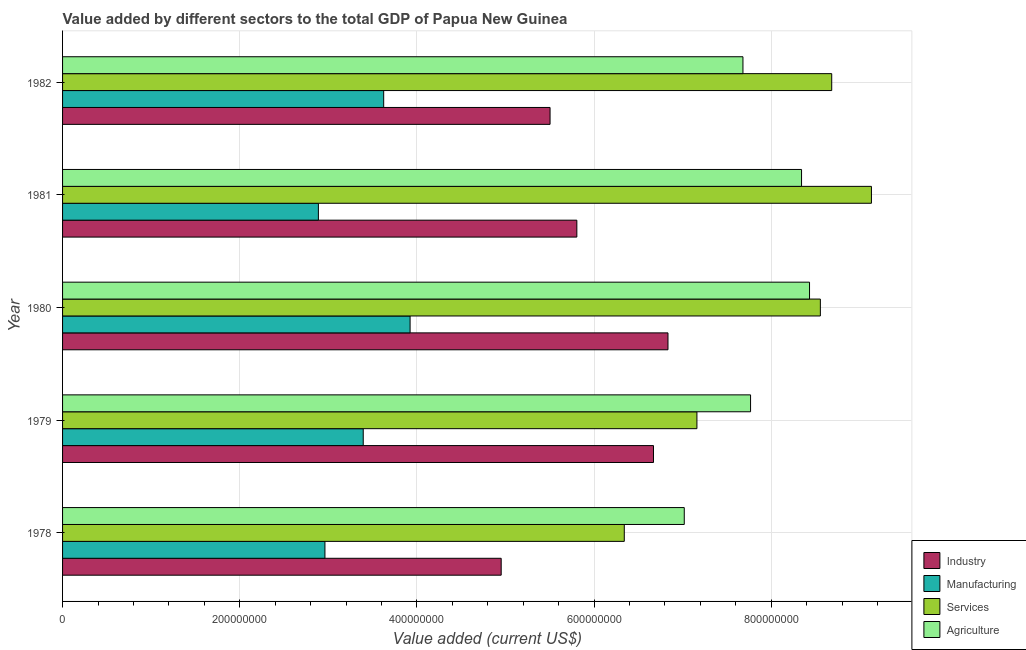How many groups of bars are there?
Provide a succinct answer. 5. Are the number of bars per tick equal to the number of legend labels?
Give a very brief answer. Yes. How many bars are there on the 1st tick from the top?
Offer a terse response. 4. How many bars are there on the 3rd tick from the bottom?
Make the answer very short. 4. What is the label of the 1st group of bars from the top?
Keep it short and to the point. 1982. In how many cases, is the number of bars for a given year not equal to the number of legend labels?
Offer a very short reply. 0. What is the value added by industrial sector in 1979?
Give a very brief answer. 6.67e+08. Across all years, what is the maximum value added by manufacturing sector?
Keep it short and to the point. 3.92e+08. Across all years, what is the minimum value added by services sector?
Make the answer very short. 6.34e+08. In which year was the value added by services sector minimum?
Ensure brevity in your answer.  1978. What is the total value added by services sector in the graph?
Your response must be concise. 3.99e+09. What is the difference between the value added by services sector in 1979 and that in 1980?
Offer a very short reply. -1.39e+08. What is the difference between the value added by services sector in 1982 and the value added by agricultural sector in 1978?
Give a very brief answer. 1.66e+08. What is the average value added by agricultural sector per year?
Your answer should be compact. 7.85e+08. In the year 1982, what is the difference between the value added by agricultural sector and value added by industrial sector?
Offer a very short reply. 2.18e+08. In how many years, is the value added by services sector greater than 160000000 US$?
Keep it short and to the point. 5. What is the ratio of the value added by industrial sector in 1978 to that in 1981?
Offer a terse response. 0.85. Is the value added by agricultural sector in 1978 less than that in 1979?
Your response must be concise. Yes. What is the difference between the highest and the second highest value added by industrial sector?
Give a very brief answer. 1.64e+07. What is the difference between the highest and the lowest value added by services sector?
Provide a short and direct response. 2.79e+08. In how many years, is the value added by agricultural sector greater than the average value added by agricultural sector taken over all years?
Make the answer very short. 2. What does the 3rd bar from the top in 1982 represents?
Provide a succinct answer. Manufacturing. What does the 1st bar from the bottom in 1978 represents?
Ensure brevity in your answer.  Industry. Is it the case that in every year, the sum of the value added by industrial sector and value added by manufacturing sector is greater than the value added by services sector?
Provide a short and direct response. No. How many years are there in the graph?
Keep it short and to the point. 5. What is the difference between two consecutive major ticks on the X-axis?
Your answer should be compact. 2.00e+08. Does the graph contain any zero values?
Make the answer very short. No. How many legend labels are there?
Give a very brief answer. 4. How are the legend labels stacked?
Make the answer very short. Vertical. What is the title of the graph?
Give a very brief answer. Value added by different sectors to the total GDP of Papua New Guinea. What is the label or title of the X-axis?
Keep it short and to the point. Value added (current US$). What is the Value added (current US$) in Industry in 1978?
Make the answer very short. 4.95e+08. What is the Value added (current US$) of Manufacturing in 1978?
Ensure brevity in your answer.  2.96e+08. What is the Value added (current US$) in Services in 1978?
Make the answer very short. 6.34e+08. What is the Value added (current US$) in Agriculture in 1978?
Your answer should be compact. 7.02e+08. What is the Value added (current US$) in Industry in 1979?
Your answer should be compact. 6.67e+08. What is the Value added (current US$) of Manufacturing in 1979?
Keep it short and to the point. 3.39e+08. What is the Value added (current US$) in Services in 1979?
Offer a terse response. 7.16e+08. What is the Value added (current US$) in Agriculture in 1979?
Provide a succinct answer. 7.77e+08. What is the Value added (current US$) of Industry in 1980?
Offer a terse response. 6.83e+08. What is the Value added (current US$) in Manufacturing in 1980?
Provide a succinct answer. 3.92e+08. What is the Value added (current US$) of Services in 1980?
Offer a very short reply. 8.55e+08. What is the Value added (current US$) in Agriculture in 1980?
Offer a terse response. 8.43e+08. What is the Value added (current US$) of Industry in 1981?
Make the answer very short. 5.81e+08. What is the Value added (current US$) in Manufacturing in 1981?
Provide a short and direct response. 2.89e+08. What is the Value added (current US$) in Services in 1981?
Offer a very short reply. 9.13e+08. What is the Value added (current US$) in Agriculture in 1981?
Your answer should be very brief. 8.34e+08. What is the Value added (current US$) of Industry in 1982?
Ensure brevity in your answer.  5.50e+08. What is the Value added (current US$) in Manufacturing in 1982?
Make the answer very short. 3.62e+08. What is the Value added (current US$) in Services in 1982?
Make the answer very short. 8.68e+08. What is the Value added (current US$) of Agriculture in 1982?
Your answer should be very brief. 7.68e+08. Across all years, what is the maximum Value added (current US$) in Industry?
Provide a succinct answer. 6.83e+08. Across all years, what is the maximum Value added (current US$) of Manufacturing?
Your answer should be compact. 3.92e+08. Across all years, what is the maximum Value added (current US$) of Services?
Provide a short and direct response. 9.13e+08. Across all years, what is the maximum Value added (current US$) in Agriculture?
Your response must be concise. 8.43e+08. Across all years, what is the minimum Value added (current US$) in Industry?
Your answer should be very brief. 4.95e+08. Across all years, what is the minimum Value added (current US$) in Manufacturing?
Your answer should be very brief. 2.89e+08. Across all years, what is the minimum Value added (current US$) in Services?
Offer a terse response. 6.34e+08. Across all years, what is the minimum Value added (current US$) in Agriculture?
Offer a terse response. 7.02e+08. What is the total Value added (current US$) of Industry in the graph?
Your answer should be very brief. 2.98e+09. What is the total Value added (current US$) in Manufacturing in the graph?
Give a very brief answer. 1.68e+09. What is the total Value added (current US$) of Services in the graph?
Provide a succinct answer. 3.99e+09. What is the total Value added (current US$) in Agriculture in the graph?
Your response must be concise. 3.92e+09. What is the difference between the Value added (current US$) of Industry in 1978 and that in 1979?
Ensure brevity in your answer.  -1.72e+08. What is the difference between the Value added (current US$) of Manufacturing in 1978 and that in 1979?
Your answer should be very brief. -4.32e+07. What is the difference between the Value added (current US$) of Services in 1978 and that in 1979?
Make the answer very short. -8.20e+07. What is the difference between the Value added (current US$) in Agriculture in 1978 and that in 1979?
Provide a succinct answer. -7.48e+07. What is the difference between the Value added (current US$) in Industry in 1978 and that in 1980?
Offer a very short reply. -1.88e+08. What is the difference between the Value added (current US$) in Manufacturing in 1978 and that in 1980?
Keep it short and to the point. -9.61e+07. What is the difference between the Value added (current US$) in Services in 1978 and that in 1980?
Your response must be concise. -2.21e+08. What is the difference between the Value added (current US$) in Agriculture in 1978 and that in 1980?
Your response must be concise. -1.41e+08. What is the difference between the Value added (current US$) of Industry in 1978 and that in 1981?
Provide a short and direct response. -8.54e+07. What is the difference between the Value added (current US$) in Manufacturing in 1978 and that in 1981?
Your answer should be compact. 7.40e+06. What is the difference between the Value added (current US$) in Services in 1978 and that in 1981?
Ensure brevity in your answer.  -2.79e+08. What is the difference between the Value added (current US$) in Agriculture in 1978 and that in 1981?
Your response must be concise. -1.32e+08. What is the difference between the Value added (current US$) of Industry in 1978 and that in 1982?
Provide a succinct answer. -5.52e+07. What is the difference between the Value added (current US$) of Manufacturing in 1978 and that in 1982?
Your answer should be compact. -6.63e+07. What is the difference between the Value added (current US$) in Services in 1978 and that in 1982?
Your response must be concise. -2.34e+08. What is the difference between the Value added (current US$) in Agriculture in 1978 and that in 1982?
Your answer should be compact. -6.63e+07. What is the difference between the Value added (current US$) of Industry in 1979 and that in 1980?
Your answer should be compact. -1.64e+07. What is the difference between the Value added (current US$) of Manufacturing in 1979 and that in 1980?
Offer a terse response. -5.29e+07. What is the difference between the Value added (current US$) of Services in 1979 and that in 1980?
Make the answer very short. -1.39e+08. What is the difference between the Value added (current US$) of Agriculture in 1979 and that in 1980?
Provide a short and direct response. -6.66e+07. What is the difference between the Value added (current US$) of Industry in 1979 and that in 1981?
Keep it short and to the point. 8.65e+07. What is the difference between the Value added (current US$) in Manufacturing in 1979 and that in 1981?
Make the answer very short. 5.06e+07. What is the difference between the Value added (current US$) in Services in 1979 and that in 1981?
Provide a succinct answer. -1.97e+08. What is the difference between the Value added (current US$) in Agriculture in 1979 and that in 1981?
Your answer should be very brief. -5.76e+07. What is the difference between the Value added (current US$) in Industry in 1979 and that in 1982?
Provide a succinct answer. 1.17e+08. What is the difference between the Value added (current US$) in Manufacturing in 1979 and that in 1982?
Provide a succinct answer. -2.31e+07. What is the difference between the Value added (current US$) in Services in 1979 and that in 1982?
Your answer should be very brief. -1.52e+08. What is the difference between the Value added (current US$) in Agriculture in 1979 and that in 1982?
Offer a terse response. 8.58e+06. What is the difference between the Value added (current US$) in Industry in 1980 and that in 1981?
Offer a terse response. 1.03e+08. What is the difference between the Value added (current US$) of Manufacturing in 1980 and that in 1981?
Your response must be concise. 1.04e+08. What is the difference between the Value added (current US$) of Services in 1980 and that in 1981?
Provide a succinct answer. -5.77e+07. What is the difference between the Value added (current US$) in Agriculture in 1980 and that in 1981?
Ensure brevity in your answer.  9.02e+06. What is the difference between the Value added (current US$) in Industry in 1980 and that in 1982?
Your response must be concise. 1.33e+08. What is the difference between the Value added (current US$) in Manufacturing in 1980 and that in 1982?
Your response must be concise. 2.98e+07. What is the difference between the Value added (current US$) of Services in 1980 and that in 1982?
Your answer should be very brief. -1.28e+07. What is the difference between the Value added (current US$) of Agriculture in 1980 and that in 1982?
Keep it short and to the point. 7.52e+07. What is the difference between the Value added (current US$) in Industry in 1981 and that in 1982?
Make the answer very short. 3.02e+07. What is the difference between the Value added (current US$) of Manufacturing in 1981 and that in 1982?
Make the answer very short. -7.37e+07. What is the difference between the Value added (current US$) in Services in 1981 and that in 1982?
Offer a terse response. 4.48e+07. What is the difference between the Value added (current US$) in Agriculture in 1981 and that in 1982?
Make the answer very short. 6.61e+07. What is the difference between the Value added (current US$) of Industry in 1978 and the Value added (current US$) of Manufacturing in 1979?
Keep it short and to the point. 1.56e+08. What is the difference between the Value added (current US$) of Industry in 1978 and the Value added (current US$) of Services in 1979?
Provide a short and direct response. -2.21e+08. What is the difference between the Value added (current US$) of Industry in 1978 and the Value added (current US$) of Agriculture in 1979?
Make the answer very short. -2.81e+08. What is the difference between the Value added (current US$) in Manufacturing in 1978 and the Value added (current US$) in Services in 1979?
Your answer should be very brief. -4.20e+08. What is the difference between the Value added (current US$) in Manufacturing in 1978 and the Value added (current US$) in Agriculture in 1979?
Your response must be concise. -4.80e+08. What is the difference between the Value added (current US$) in Services in 1978 and the Value added (current US$) in Agriculture in 1979?
Provide a short and direct response. -1.43e+08. What is the difference between the Value added (current US$) of Industry in 1978 and the Value added (current US$) of Manufacturing in 1980?
Give a very brief answer. 1.03e+08. What is the difference between the Value added (current US$) in Industry in 1978 and the Value added (current US$) in Services in 1980?
Your answer should be very brief. -3.60e+08. What is the difference between the Value added (current US$) of Industry in 1978 and the Value added (current US$) of Agriculture in 1980?
Offer a terse response. -3.48e+08. What is the difference between the Value added (current US$) of Manufacturing in 1978 and the Value added (current US$) of Services in 1980?
Your answer should be compact. -5.59e+08. What is the difference between the Value added (current US$) in Manufacturing in 1978 and the Value added (current US$) in Agriculture in 1980?
Provide a succinct answer. -5.47e+08. What is the difference between the Value added (current US$) of Services in 1978 and the Value added (current US$) of Agriculture in 1980?
Your answer should be compact. -2.09e+08. What is the difference between the Value added (current US$) in Industry in 1978 and the Value added (current US$) in Manufacturing in 1981?
Offer a terse response. 2.06e+08. What is the difference between the Value added (current US$) in Industry in 1978 and the Value added (current US$) in Services in 1981?
Ensure brevity in your answer.  -4.18e+08. What is the difference between the Value added (current US$) in Industry in 1978 and the Value added (current US$) in Agriculture in 1981?
Provide a short and direct response. -3.39e+08. What is the difference between the Value added (current US$) in Manufacturing in 1978 and the Value added (current US$) in Services in 1981?
Give a very brief answer. -6.17e+08. What is the difference between the Value added (current US$) of Manufacturing in 1978 and the Value added (current US$) of Agriculture in 1981?
Ensure brevity in your answer.  -5.38e+08. What is the difference between the Value added (current US$) in Services in 1978 and the Value added (current US$) in Agriculture in 1981?
Ensure brevity in your answer.  -2.00e+08. What is the difference between the Value added (current US$) of Industry in 1978 and the Value added (current US$) of Manufacturing in 1982?
Offer a very short reply. 1.33e+08. What is the difference between the Value added (current US$) in Industry in 1978 and the Value added (current US$) in Services in 1982?
Make the answer very short. -3.73e+08. What is the difference between the Value added (current US$) in Industry in 1978 and the Value added (current US$) in Agriculture in 1982?
Give a very brief answer. -2.73e+08. What is the difference between the Value added (current US$) in Manufacturing in 1978 and the Value added (current US$) in Services in 1982?
Offer a terse response. -5.72e+08. What is the difference between the Value added (current US$) of Manufacturing in 1978 and the Value added (current US$) of Agriculture in 1982?
Your answer should be compact. -4.72e+08. What is the difference between the Value added (current US$) of Services in 1978 and the Value added (current US$) of Agriculture in 1982?
Give a very brief answer. -1.34e+08. What is the difference between the Value added (current US$) of Industry in 1979 and the Value added (current US$) of Manufacturing in 1980?
Ensure brevity in your answer.  2.75e+08. What is the difference between the Value added (current US$) in Industry in 1979 and the Value added (current US$) in Services in 1980?
Your answer should be compact. -1.88e+08. What is the difference between the Value added (current US$) of Industry in 1979 and the Value added (current US$) of Agriculture in 1980?
Make the answer very short. -1.76e+08. What is the difference between the Value added (current US$) of Manufacturing in 1979 and the Value added (current US$) of Services in 1980?
Offer a terse response. -5.16e+08. What is the difference between the Value added (current US$) in Manufacturing in 1979 and the Value added (current US$) in Agriculture in 1980?
Your answer should be very brief. -5.04e+08. What is the difference between the Value added (current US$) in Services in 1979 and the Value added (current US$) in Agriculture in 1980?
Make the answer very short. -1.27e+08. What is the difference between the Value added (current US$) in Industry in 1979 and the Value added (current US$) in Manufacturing in 1981?
Keep it short and to the point. 3.78e+08. What is the difference between the Value added (current US$) in Industry in 1979 and the Value added (current US$) in Services in 1981?
Make the answer very short. -2.46e+08. What is the difference between the Value added (current US$) in Industry in 1979 and the Value added (current US$) in Agriculture in 1981?
Your answer should be compact. -1.67e+08. What is the difference between the Value added (current US$) of Manufacturing in 1979 and the Value added (current US$) of Services in 1981?
Your answer should be compact. -5.74e+08. What is the difference between the Value added (current US$) in Manufacturing in 1979 and the Value added (current US$) in Agriculture in 1981?
Your answer should be compact. -4.95e+08. What is the difference between the Value added (current US$) in Services in 1979 and the Value added (current US$) in Agriculture in 1981?
Keep it short and to the point. -1.18e+08. What is the difference between the Value added (current US$) of Industry in 1979 and the Value added (current US$) of Manufacturing in 1982?
Your answer should be compact. 3.05e+08. What is the difference between the Value added (current US$) in Industry in 1979 and the Value added (current US$) in Services in 1982?
Provide a short and direct response. -2.01e+08. What is the difference between the Value added (current US$) of Industry in 1979 and the Value added (current US$) of Agriculture in 1982?
Your response must be concise. -1.01e+08. What is the difference between the Value added (current US$) of Manufacturing in 1979 and the Value added (current US$) of Services in 1982?
Provide a short and direct response. -5.29e+08. What is the difference between the Value added (current US$) in Manufacturing in 1979 and the Value added (current US$) in Agriculture in 1982?
Offer a terse response. -4.29e+08. What is the difference between the Value added (current US$) in Services in 1979 and the Value added (current US$) in Agriculture in 1982?
Provide a short and direct response. -5.20e+07. What is the difference between the Value added (current US$) of Industry in 1980 and the Value added (current US$) of Manufacturing in 1981?
Your answer should be very brief. 3.95e+08. What is the difference between the Value added (current US$) in Industry in 1980 and the Value added (current US$) in Services in 1981?
Make the answer very short. -2.30e+08. What is the difference between the Value added (current US$) in Industry in 1980 and the Value added (current US$) in Agriculture in 1981?
Provide a succinct answer. -1.51e+08. What is the difference between the Value added (current US$) of Manufacturing in 1980 and the Value added (current US$) of Services in 1981?
Make the answer very short. -5.21e+08. What is the difference between the Value added (current US$) in Manufacturing in 1980 and the Value added (current US$) in Agriculture in 1981?
Keep it short and to the point. -4.42e+08. What is the difference between the Value added (current US$) in Services in 1980 and the Value added (current US$) in Agriculture in 1981?
Make the answer very short. 2.12e+07. What is the difference between the Value added (current US$) of Industry in 1980 and the Value added (current US$) of Manufacturing in 1982?
Keep it short and to the point. 3.21e+08. What is the difference between the Value added (current US$) in Industry in 1980 and the Value added (current US$) in Services in 1982?
Offer a terse response. -1.85e+08. What is the difference between the Value added (current US$) in Industry in 1980 and the Value added (current US$) in Agriculture in 1982?
Your answer should be compact. -8.46e+07. What is the difference between the Value added (current US$) of Manufacturing in 1980 and the Value added (current US$) of Services in 1982?
Offer a terse response. -4.76e+08. What is the difference between the Value added (current US$) in Manufacturing in 1980 and the Value added (current US$) in Agriculture in 1982?
Keep it short and to the point. -3.76e+08. What is the difference between the Value added (current US$) of Services in 1980 and the Value added (current US$) of Agriculture in 1982?
Offer a terse response. 8.74e+07. What is the difference between the Value added (current US$) in Industry in 1981 and the Value added (current US$) in Manufacturing in 1982?
Provide a short and direct response. 2.18e+08. What is the difference between the Value added (current US$) in Industry in 1981 and the Value added (current US$) in Services in 1982?
Keep it short and to the point. -2.88e+08. What is the difference between the Value added (current US$) of Industry in 1981 and the Value added (current US$) of Agriculture in 1982?
Provide a succinct answer. -1.88e+08. What is the difference between the Value added (current US$) in Manufacturing in 1981 and the Value added (current US$) in Services in 1982?
Offer a terse response. -5.79e+08. What is the difference between the Value added (current US$) of Manufacturing in 1981 and the Value added (current US$) of Agriculture in 1982?
Provide a succinct answer. -4.79e+08. What is the difference between the Value added (current US$) of Services in 1981 and the Value added (current US$) of Agriculture in 1982?
Your answer should be very brief. 1.45e+08. What is the average Value added (current US$) in Industry per year?
Keep it short and to the point. 5.95e+08. What is the average Value added (current US$) in Manufacturing per year?
Your answer should be compact. 3.36e+08. What is the average Value added (current US$) of Services per year?
Offer a very short reply. 7.97e+08. What is the average Value added (current US$) in Agriculture per year?
Your response must be concise. 7.85e+08. In the year 1978, what is the difference between the Value added (current US$) in Industry and Value added (current US$) in Manufacturing?
Offer a very short reply. 1.99e+08. In the year 1978, what is the difference between the Value added (current US$) in Industry and Value added (current US$) in Services?
Offer a very short reply. -1.39e+08. In the year 1978, what is the difference between the Value added (current US$) of Industry and Value added (current US$) of Agriculture?
Ensure brevity in your answer.  -2.07e+08. In the year 1978, what is the difference between the Value added (current US$) in Manufacturing and Value added (current US$) in Services?
Keep it short and to the point. -3.38e+08. In the year 1978, what is the difference between the Value added (current US$) in Manufacturing and Value added (current US$) in Agriculture?
Your answer should be very brief. -4.06e+08. In the year 1978, what is the difference between the Value added (current US$) of Services and Value added (current US$) of Agriculture?
Your answer should be compact. -6.77e+07. In the year 1979, what is the difference between the Value added (current US$) of Industry and Value added (current US$) of Manufacturing?
Make the answer very short. 3.28e+08. In the year 1979, what is the difference between the Value added (current US$) of Industry and Value added (current US$) of Services?
Make the answer very short. -4.90e+07. In the year 1979, what is the difference between the Value added (current US$) in Industry and Value added (current US$) in Agriculture?
Offer a terse response. -1.10e+08. In the year 1979, what is the difference between the Value added (current US$) in Manufacturing and Value added (current US$) in Services?
Your response must be concise. -3.77e+08. In the year 1979, what is the difference between the Value added (current US$) in Manufacturing and Value added (current US$) in Agriculture?
Your answer should be compact. -4.37e+08. In the year 1979, what is the difference between the Value added (current US$) of Services and Value added (current US$) of Agriculture?
Make the answer very short. -6.06e+07. In the year 1980, what is the difference between the Value added (current US$) of Industry and Value added (current US$) of Manufacturing?
Provide a succinct answer. 2.91e+08. In the year 1980, what is the difference between the Value added (current US$) of Industry and Value added (current US$) of Services?
Provide a succinct answer. -1.72e+08. In the year 1980, what is the difference between the Value added (current US$) of Industry and Value added (current US$) of Agriculture?
Keep it short and to the point. -1.60e+08. In the year 1980, what is the difference between the Value added (current US$) in Manufacturing and Value added (current US$) in Services?
Give a very brief answer. -4.63e+08. In the year 1980, what is the difference between the Value added (current US$) in Manufacturing and Value added (current US$) in Agriculture?
Offer a terse response. -4.51e+08. In the year 1980, what is the difference between the Value added (current US$) of Services and Value added (current US$) of Agriculture?
Make the answer very short. 1.22e+07. In the year 1981, what is the difference between the Value added (current US$) in Industry and Value added (current US$) in Manufacturing?
Ensure brevity in your answer.  2.92e+08. In the year 1981, what is the difference between the Value added (current US$) of Industry and Value added (current US$) of Services?
Offer a terse response. -3.33e+08. In the year 1981, what is the difference between the Value added (current US$) in Industry and Value added (current US$) in Agriculture?
Your response must be concise. -2.54e+08. In the year 1981, what is the difference between the Value added (current US$) in Manufacturing and Value added (current US$) in Services?
Provide a short and direct response. -6.24e+08. In the year 1981, what is the difference between the Value added (current US$) of Manufacturing and Value added (current US$) of Agriculture?
Ensure brevity in your answer.  -5.45e+08. In the year 1981, what is the difference between the Value added (current US$) in Services and Value added (current US$) in Agriculture?
Give a very brief answer. 7.89e+07. In the year 1982, what is the difference between the Value added (current US$) of Industry and Value added (current US$) of Manufacturing?
Make the answer very short. 1.88e+08. In the year 1982, what is the difference between the Value added (current US$) in Industry and Value added (current US$) in Services?
Your response must be concise. -3.18e+08. In the year 1982, what is the difference between the Value added (current US$) in Industry and Value added (current US$) in Agriculture?
Offer a terse response. -2.18e+08. In the year 1982, what is the difference between the Value added (current US$) in Manufacturing and Value added (current US$) in Services?
Ensure brevity in your answer.  -5.06e+08. In the year 1982, what is the difference between the Value added (current US$) of Manufacturing and Value added (current US$) of Agriculture?
Provide a short and direct response. -4.06e+08. In the year 1982, what is the difference between the Value added (current US$) of Services and Value added (current US$) of Agriculture?
Offer a very short reply. 1.00e+08. What is the ratio of the Value added (current US$) of Industry in 1978 to that in 1979?
Make the answer very short. 0.74. What is the ratio of the Value added (current US$) in Manufacturing in 1978 to that in 1979?
Offer a very short reply. 0.87. What is the ratio of the Value added (current US$) of Services in 1978 to that in 1979?
Your response must be concise. 0.89. What is the ratio of the Value added (current US$) in Agriculture in 1978 to that in 1979?
Give a very brief answer. 0.9. What is the ratio of the Value added (current US$) in Industry in 1978 to that in 1980?
Give a very brief answer. 0.72. What is the ratio of the Value added (current US$) in Manufacturing in 1978 to that in 1980?
Your response must be concise. 0.76. What is the ratio of the Value added (current US$) of Services in 1978 to that in 1980?
Make the answer very short. 0.74. What is the ratio of the Value added (current US$) of Agriculture in 1978 to that in 1980?
Keep it short and to the point. 0.83. What is the ratio of the Value added (current US$) of Industry in 1978 to that in 1981?
Make the answer very short. 0.85. What is the ratio of the Value added (current US$) in Manufacturing in 1978 to that in 1981?
Offer a terse response. 1.03. What is the ratio of the Value added (current US$) of Services in 1978 to that in 1981?
Make the answer very short. 0.69. What is the ratio of the Value added (current US$) in Agriculture in 1978 to that in 1981?
Offer a terse response. 0.84. What is the ratio of the Value added (current US$) of Industry in 1978 to that in 1982?
Ensure brevity in your answer.  0.9. What is the ratio of the Value added (current US$) of Manufacturing in 1978 to that in 1982?
Your response must be concise. 0.82. What is the ratio of the Value added (current US$) of Services in 1978 to that in 1982?
Make the answer very short. 0.73. What is the ratio of the Value added (current US$) in Agriculture in 1978 to that in 1982?
Provide a succinct answer. 0.91. What is the ratio of the Value added (current US$) in Manufacturing in 1979 to that in 1980?
Offer a very short reply. 0.87. What is the ratio of the Value added (current US$) in Services in 1979 to that in 1980?
Keep it short and to the point. 0.84. What is the ratio of the Value added (current US$) of Agriculture in 1979 to that in 1980?
Provide a short and direct response. 0.92. What is the ratio of the Value added (current US$) of Industry in 1979 to that in 1981?
Provide a short and direct response. 1.15. What is the ratio of the Value added (current US$) of Manufacturing in 1979 to that in 1981?
Keep it short and to the point. 1.18. What is the ratio of the Value added (current US$) in Services in 1979 to that in 1981?
Provide a short and direct response. 0.78. What is the ratio of the Value added (current US$) of Agriculture in 1979 to that in 1981?
Make the answer very short. 0.93. What is the ratio of the Value added (current US$) in Industry in 1979 to that in 1982?
Ensure brevity in your answer.  1.21. What is the ratio of the Value added (current US$) in Manufacturing in 1979 to that in 1982?
Give a very brief answer. 0.94. What is the ratio of the Value added (current US$) of Services in 1979 to that in 1982?
Offer a terse response. 0.82. What is the ratio of the Value added (current US$) of Agriculture in 1979 to that in 1982?
Provide a succinct answer. 1.01. What is the ratio of the Value added (current US$) of Industry in 1980 to that in 1981?
Keep it short and to the point. 1.18. What is the ratio of the Value added (current US$) in Manufacturing in 1980 to that in 1981?
Provide a short and direct response. 1.36. What is the ratio of the Value added (current US$) in Services in 1980 to that in 1981?
Keep it short and to the point. 0.94. What is the ratio of the Value added (current US$) of Agriculture in 1980 to that in 1981?
Keep it short and to the point. 1.01. What is the ratio of the Value added (current US$) of Industry in 1980 to that in 1982?
Provide a succinct answer. 1.24. What is the ratio of the Value added (current US$) of Manufacturing in 1980 to that in 1982?
Keep it short and to the point. 1.08. What is the ratio of the Value added (current US$) of Services in 1980 to that in 1982?
Provide a succinct answer. 0.99. What is the ratio of the Value added (current US$) in Agriculture in 1980 to that in 1982?
Give a very brief answer. 1.1. What is the ratio of the Value added (current US$) of Industry in 1981 to that in 1982?
Your answer should be compact. 1.05. What is the ratio of the Value added (current US$) of Manufacturing in 1981 to that in 1982?
Your answer should be very brief. 0.8. What is the ratio of the Value added (current US$) in Services in 1981 to that in 1982?
Keep it short and to the point. 1.05. What is the ratio of the Value added (current US$) in Agriculture in 1981 to that in 1982?
Provide a succinct answer. 1.09. What is the difference between the highest and the second highest Value added (current US$) in Industry?
Your answer should be compact. 1.64e+07. What is the difference between the highest and the second highest Value added (current US$) in Manufacturing?
Offer a very short reply. 2.98e+07. What is the difference between the highest and the second highest Value added (current US$) of Services?
Provide a succinct answer. 4.48e+07. What is the difference between the highest and the second highest Value added (current US$) in Agriculture?
Your response must be concise. 9.02e+06. What is the difference between the highest and the lowest Value added (current US$) of Industry?
Offer a terse response. 1.88e+08. What is the difference between the highest and the lowest Value added (current US$) of Manufacturing?
Provide a short and direct response. 1.04e+08. What is the difference between the highest and the lowest Value added (current US$) of Services?
Your answer should be very brief. 2.79e+08. What is the difference between the highest and the lowest Value added (current US$) in Agriculture?
Offer a very short reply. 1.41e+08. 